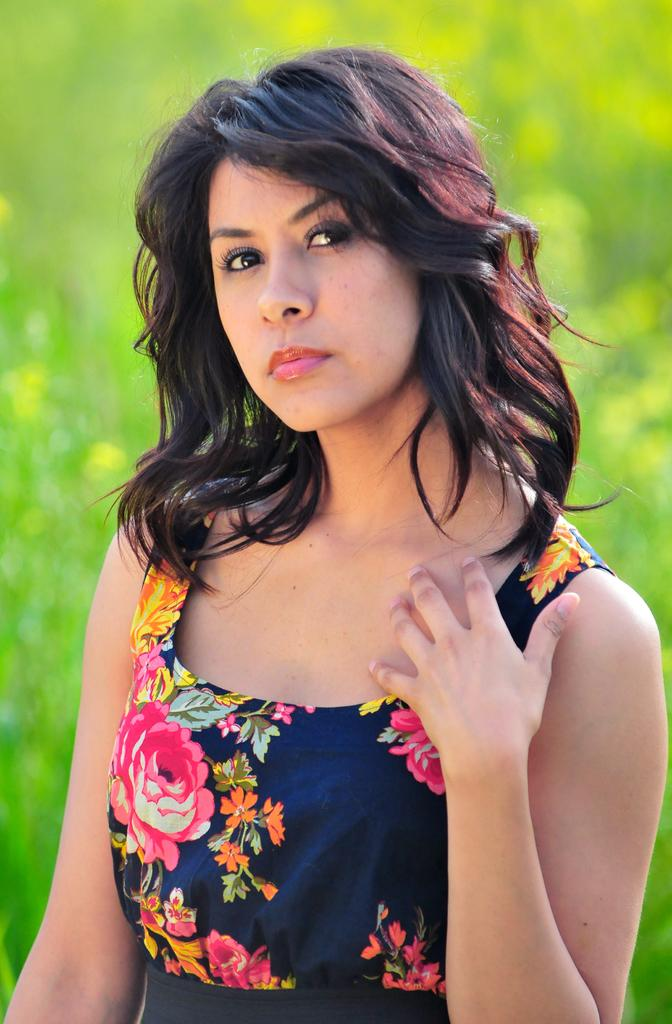What is present in the image? There is a person in the image. Can you describe the person's attire? The person is wearing clothes. What type of quiver is the person holding in the image? There is no quiver present in the image. Is the person wearing a crown in the image? There is no crown present in the image. 